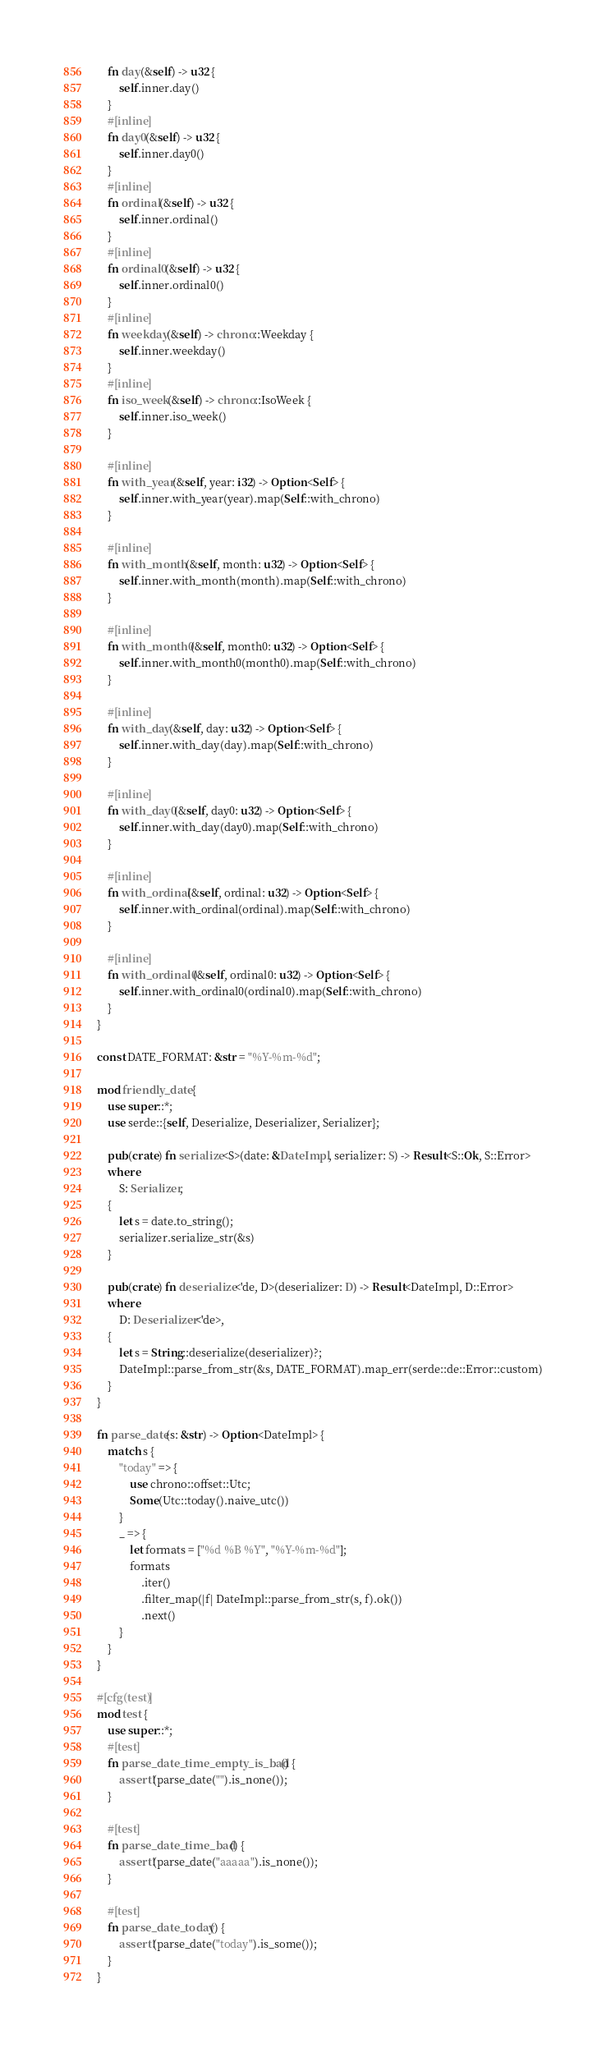Convert code to text. <code><loc_0><loc_0><loc_500><loc_500><_Rust_>    fn day(&self) -> u32 {
        self.inner.day()
    }
    #[inline]
    fn day0(&self) -> u32 {
        self.inner.day0()
    }
    #[inline]
    fn ordinal(&self) -> u32 {
        self.inner.ordinal()
    }
    #[inline]
    fn ordinal0(&self) -> u32 {
        self.inner.ordinal0()
    }
    #[inline]
    fn weekday(&self) -> chrono::Weekday {
        self.inner.weekday()
    }
    #[inline]
    fn iso_week(&self) -> chrono::IsoWeek {
        self.inner.iso_week()
    }

    #[inline]
    fn with_year(&self, year: i32) -> Option<Self> {
        self.inner.with_year(year).map(Self::with_chrono)
    }

    #[inline]
    fn with_month(&self, month: u32) -> Option<Self> {
        self.inner.with_month(month).map(Self::with_chrono)
    }

    #[inline]
    fn with_month0(&self, month0: u32) -> Option<Self> {
        self.inner.with_month0(month0).map(Self::with_chrono)
    }

    #[inline]
    fn with_day(&self, day: u32) -> Option<Self> {
        self.inner.with_day(day).map(Self::with_chrono)
    }

    #[inline]
    fn with_day0(&self, day0: u32) -> Option<Self> {
        self.inner.with_day(day0).map(Self::with_chrono)
    }

    #[inline]
    fn with_ordinal(&self, ordinal: u32) -> Option<Self> {
        self.inner.with_ordinal(ordinal).map(Self::with_chrono)
    }

    #[inline]
    fn with_ordinal0(&self, ordinal0: u32) -> Option<Self> {
        self.inner.with_ordinal0(ordinal0).map(Self::with_chrono)
    }
}

const DATE_FORMAT: &str = "%Y-%m-%d";

mod friendly_date {
    use super::*;
    use serde::{self, Deserialize, Deserializer, Serializer};

    pub(crate) fn serialize<S>(date: &DateImpl, serializer: S) -> Result<S::Ok, S::Error>
    where
        S: Serializer,
    {
        let s = date.to_string();
        serializer.serialize_str(&s)
    }

    pub(crate) fn deserialize<'de, D>(deserializer: D) -> Result<DateImpl, D::Error>
    where
        D: Deserializer<'de>,
    {
        let s = String::deserialize(deserializer)?;
        DateImpl::parse_from_str(&s, DATE_FORMAT).map_err(serde::de::Error::custom)
    }
}

fn parse_date(s: &str) -> Option<DateImpl> {
    match s {
        "today" => {
            use chrono::offset::Utc;
            Some(Utc::today().naive_utc())
        }
        _ => {
            let formats = ["%d %B %Y", "%Y-%m-%d"];
            formats
                .iter()
                .filter_map(|f| DateImpl::parse_from_str(s, f).ok())
                .next()
        }
    }
}

#[cfg(test)]
mod test {
    use super::*;
    #[test]
    fn parse_date_time_empty_is_bad() {
        assert!(parse_date("").is_none());
    }

    #[test]
    fn parse_date_time_bad() {
        assert!(parse_date("aaaaa").is_none());
    }

    #[test]
    fn parse_date_today() {
        assert!(parse_date("today").is_some());
    }
}
</code> 